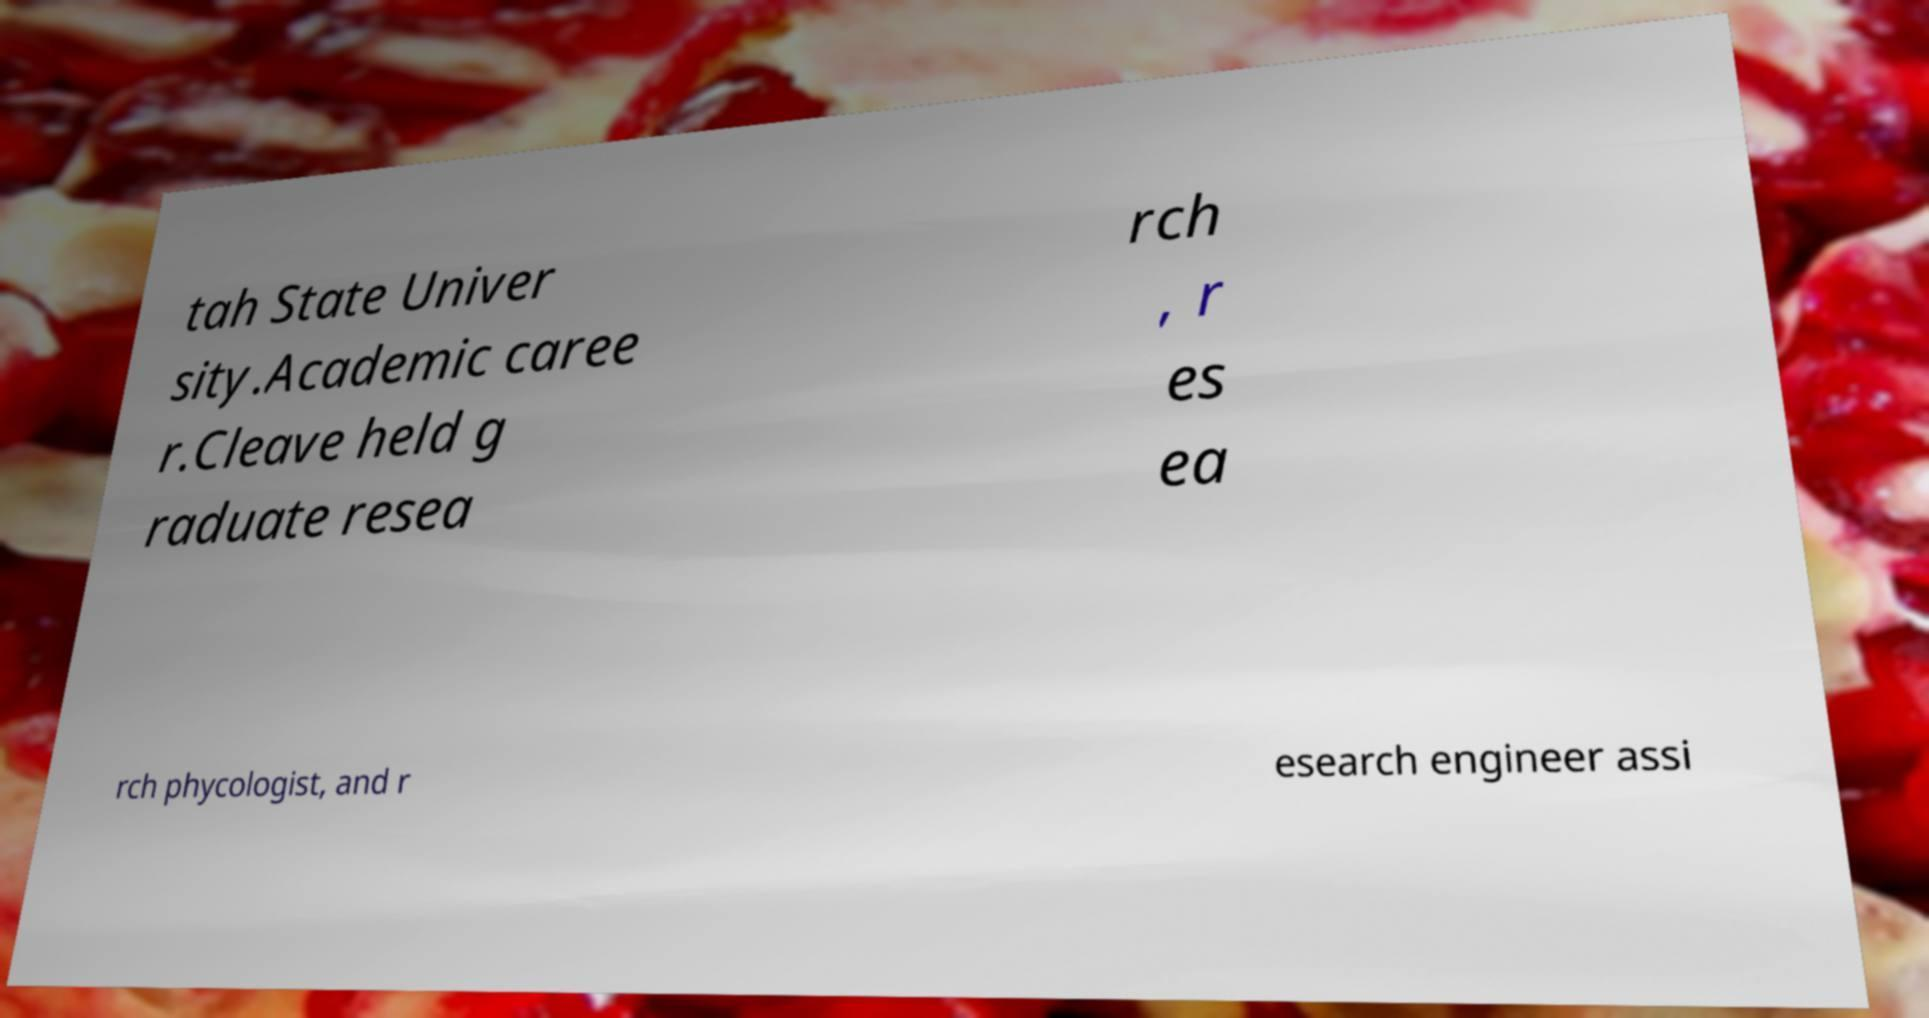Can you read and provide the text displayed in the image?This photo seems to have some interesting text. Can you extract and type it out for me? tah State Univer sity.Academic caree r.Cleave held g raduate resea rch , r es ea rch phycologist, and r esearch engineer assi 